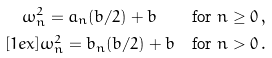<formula> <loc_0><loc_0><loc_500><loc_500>\omega ^ { 2 } _ { n } = a _ { n } ( b / 2 ) + b \quad & \text {for $n\geq 0$} \, , \\ [ 1 e x ] \omega ^ { 2 } _ { n } = b _ { n } ( b / 2 ) + b \quad & \text {for $n> 0$} \, .</formula> 